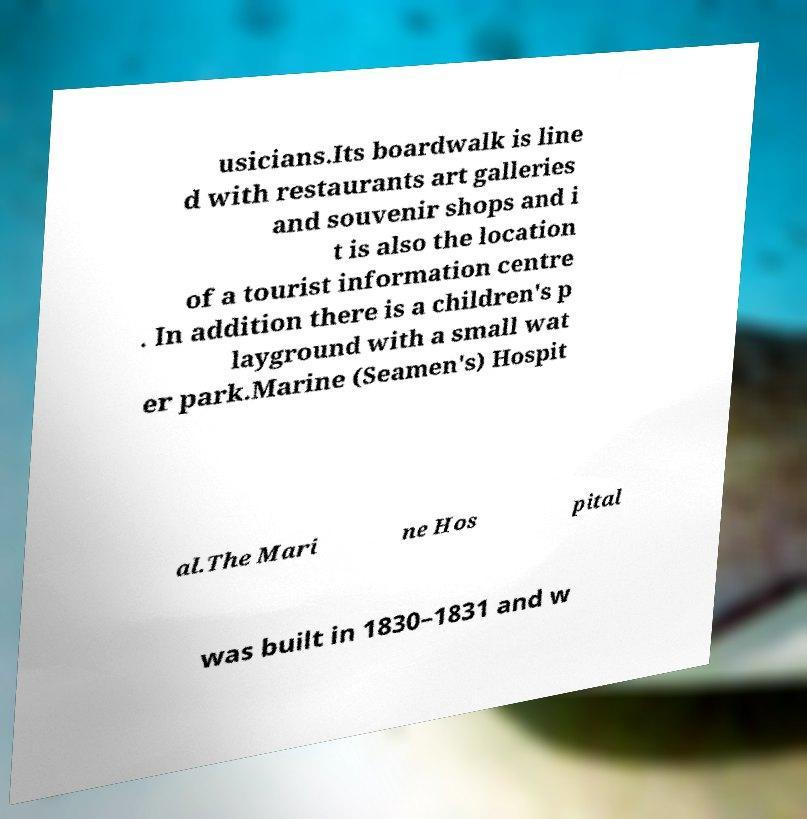For documentation purposes, I need the text within this image transcribed. Could you provide that? usicians.Its boardwalk is line d with restaurants art galleries and souvenir shops and i t is also the location of a tourist information centre . In addition there is a children's p layground with a small wat er park.Marine (Seamen's) Hospit al.The Mari ne Hos pital was built in 1830–1831 and w 